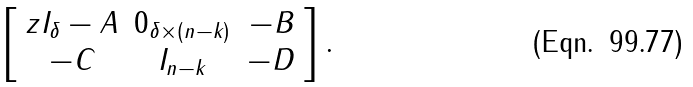Convert formula to latex. <formula><loc_0><loc_0><loc_500><loc_500>\left [ \begin{array} { c c c } z I _ { \delta } - A & 0 _ { \delta \times ( n - k ) } & - B \\ - C & I _ { n - k } & - D \end{array} \right ] .</formula> 